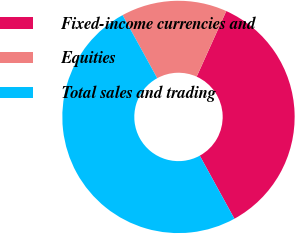Convert chart. <chart><loc_0><loc_0><loc_500><loc_500><pie_chart><fcel>Fixed-income currencies and<fcel>Equities<fcel>Total sales and trading<nl><fcel>35.26%<fcel>14.74%<fcel>50.0%<nl></chart> 